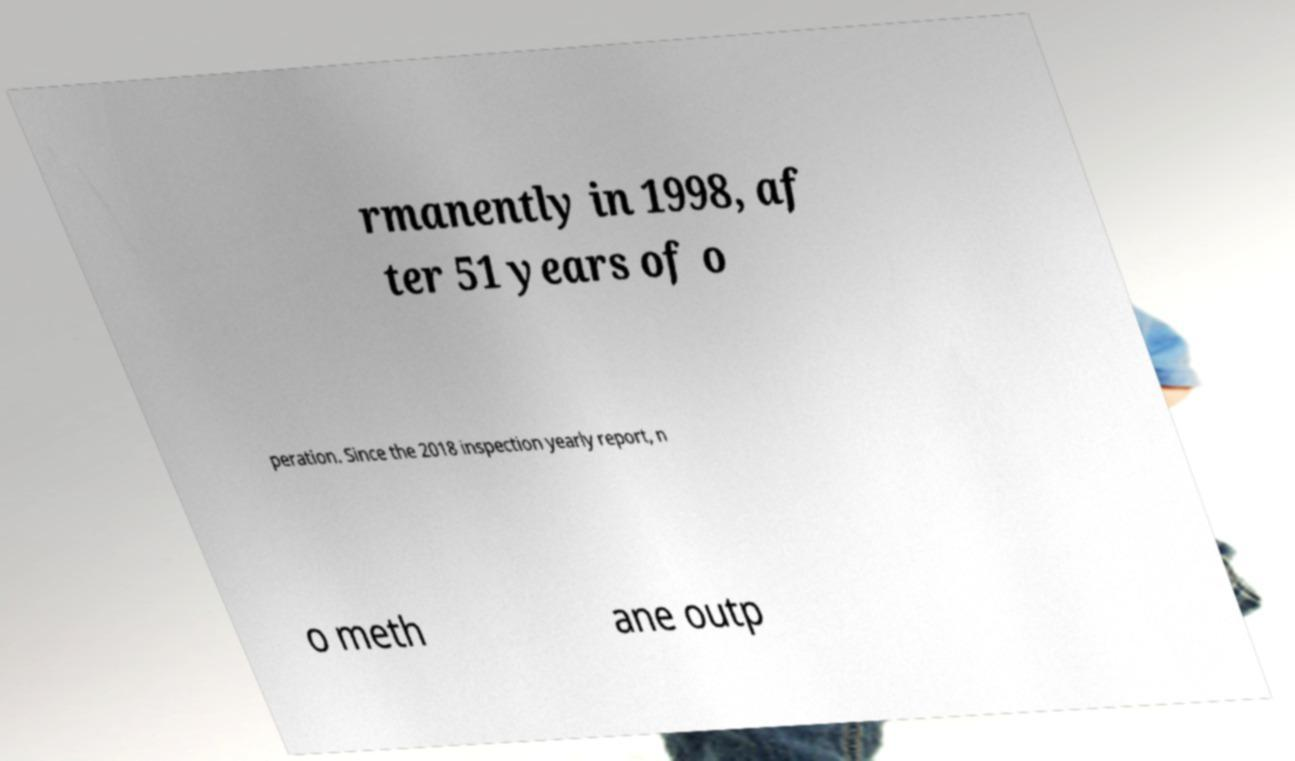Can you accurately transcribe the text from the provided image for me? rmanently in 1998, af ter 51 years of o peration. Since the 2018 inspection yearly report, n o meth ane outp 